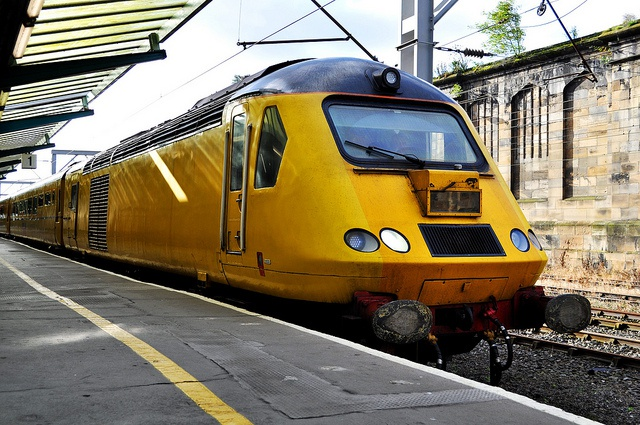Describe the objects in this image and their specific colors. I can see a train in black, orange, olive, and maroon tones in this image. 